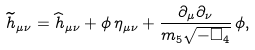Convert formula to latex. <formula><loc_0><loc_0><loc_500><loc_500>\widetilde { h } _ { \mu \nu } = \widehat { h } _ { \mu \nu } + \phi \, \eta _ { \mu \nu } + \frac { \partial _ { \mu } \partial _ { \nu } } { m _ { 5 } \sqrt { - \Box _ { 4 } } } \, \phi ,</formula> 